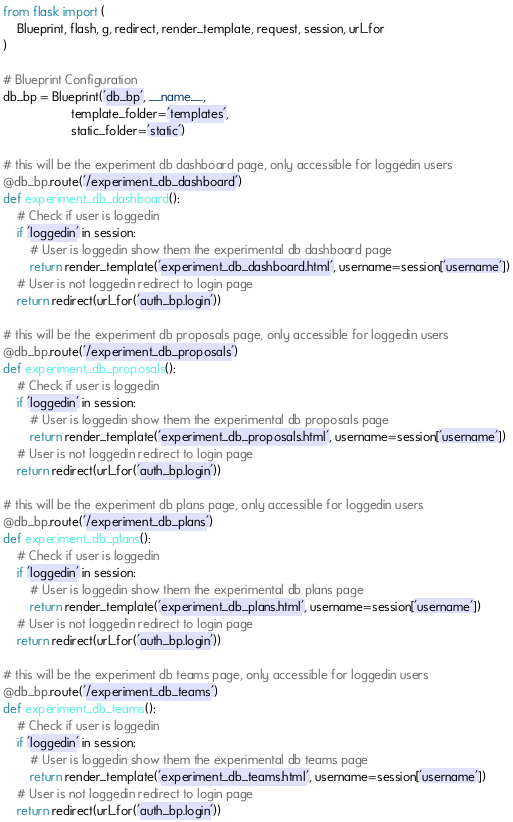Convert code to text. <code><loc_0><loc_0><loc_500><loc_500><_Python_>from flask import (
    Blueprint, flash, g, redirect, render_template, request, session, url_for
)

# Blueprint Configuration
db_bp = Blueprint('db_bp', __name__,
                    template_folder='templates',
                    static_folder='static')

# this will be the experiment db dashboard page, only accessible for loggedin users
@db_bp.route('/experiment_db_dashboard')
def experiment_db_dashboard():
    # Check if user is loggedin
    if 'loggedin' in session:
        # User is loggedin show them the experimental db dashboard page
        return render_template('experiment_db_dashboard.html', username=session['username'])
    # User is not loggedin redirect to login page
    return redirect(url_for('auth_bp.login'))

# this will be the experiment db proposals page, only accessible for loggedin users
@db_bp.route('/experiment_db_proposals')
def experiment_db_proposals():
    # Check if user is loggedin
    if 'loggedin' in session:
        # User is loggedin show them the experimental db proposals page
        return render_template('experiment_db_proposals.html', username=session['username'])
    # User is not loggedin redirect to login page
    return redirect(url_for('auth_bp.login'))

# this will be the experiment db plans page, only accessible for loggedin users
@db_bp.route('/experiment_db_plans')
def experiment_db_plans():
    # Check if user is loggedin
    if 'loggedin' in session:
        # User is loggedin show them the experimental db plans page
        return render_template('experiment_db_plans.html', username=session['username'])
    # User is not loggedin redirect to login page
    return redirect(url_for('auth_bp.login'))

# this will be the experiment db teams page, only accessible for loggedin users
@db_bp.route('/experiment_db_teams')
def experiment_db_teams():
    # Check if user is loggedin
    if 'loggedin' in session:
        # User is loggedin show them the experimental db teams page
        return render_template('experiment_db_teams.html', username=session['username'])
    # User is not loggedin redirect to login page
    return redirect(url_for('auth_bp.login'))</code> 